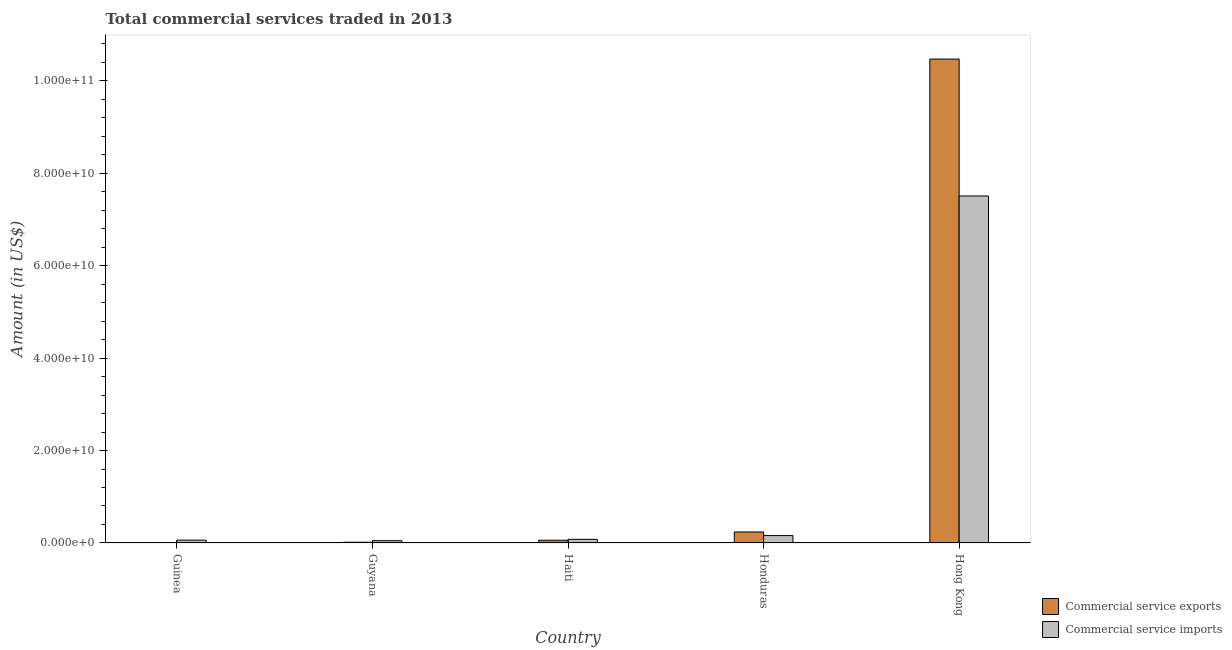How many different coloured bars are there?
Offer a terse response. 2. How many groups of bars are there?
Your answer should be very brief. 5. Are the number of bars on each tick of the X-axis equal?
Provide a short and direct response. Yes. What is the label of the 4th group of bars from the left?
Offer a very short reply. Honduras. In how many cases, is the number of bars for a given country not equal to the number of legend labels?
Keep it short and to the point. 0. What is the amount of commercial service exports in Honduras?
Your answer should be compact. 2.39e+09. Across all countries, what is the maximum amount of commercial service imports?
Your answer should be very brief. 7.50e+1. Across all countries, what is the minimum amount of commercial service imports?
Provide a short and direct response. 5.00e+08. In which country was the amount of commercial service exports maximum?
Provide a succinct answer. Hong Kong. In which country was the amount of commercial service exports minimum?
Provide a succinct answer. Guinea. What is the total amount of commercial service imports in the graph?
Ensure brevity in your answer.  7.86e+1. What is the difference between the amount of commercial service imports in Guyana and that in Haiti?
Give a very brief answer. -2.91e+08. What is the difference between the amount of commercial service imports in Honduras and the amount of commercial service exports in Guinea?
Your answer should be very brief. 1.50e+09. What is the average amount of commercial service imports per country?
Make the answer very short. 1.57e+1. What is the difference between the amount of commercial service imports and amount of commercial service exports in Haiti?
Provide a short and direct response. 1.96e+08. In how many countries, is the amount of commercial service imports greater than 64000000000 US$?
Your answer should be very brief. 1. What is the ratio of the amount of commercial service imports in Guinea to that in Guyana?
Provide a short and direct response. 1.24. Is the amount of commercial service imports in Haiti less than that in Honduras?
Provide a succinct answer. Yes. What is the difference between the highest and the second highest amount of commercial service exports?
Your answer should be compact. 1.02e+11. What is the difference between the highest and the lowest amount of commercial service exports?
Offer a very short reply. 1.05e+11. In how many countries, is the amount of commercial service exports greater than the average amount of commercial service exports taken over all countries?
Make the answer very short. 1. What does the 2nd bar from the left in Guyana represents?
Your answer should be very brief. Commercial service imports. What does the 2nd bar from the right in Hong Kong represents?
Your answer should be compact. Commercial service exports. What is the difference between two consecutive major ticks on the Y-axis?
Offer a terse response. 2.00e+1. Are the values on the major ticks of Y-axis written in scientific E-notation?
Your response must be concise. Yes. Does the graph contain any zero values?
Provide a short and direct response. No. Where does the legend appear in the graph?
Provide a short and direct response. Bottom right. How many legend labels are there?
Offer a terse response. 2. How are the legend labels stacked?
Provide a short and direct response. Vertical. What is the title of the graph?
Provide a short and direct response. Total commercial services traded in 2013. Does "Central government" appear as one of the legend labels in the graph?
Offer a terse response. No. What is the label or title of the Y-axis?
Give a very brief answer. Amount (in US$). What is the Amount (in US$) of Commercial service exports in Guinea?
Your answer should be very brief. 1.00e+08. What is the Amount (in US$) in Commercial service imports in Guinea?
Provide a succinct answer. 6.19e+08. What is the Amount (in US$) of Commercial service exports in Guyana?
Offer a very short reply. 1.65e+08. What is the Amount (in US$) of Commercial service imports in Guyana?
Give a very brief answer. 5.00e+08. What is the Amount (in US$) of Commercial service exports in Haiti?
Provide a short and direct response. 5.95e+08. What is the Amount (in US$) of Commercial service imports in Haiti?
Offer a very short reply. 7.92e+08. What is the Amount (in US$) in Commercial service exports in Honduras?
Ensure brevity in your answer.  2.39e+09. What is the Amount (in US$) in Commercial service imports in Honduras?
Make the answer very short. 1.60e+09. What is the Amount (in US$) in Commercial service exports in Hong Kong?
Make the answer very short. 1.05e+11. What is the Amount (in US$) in Commercial service imports in Hong Kong?
Provide a short and direct response. 7.50e+1. Across all countries, what is the maximum Amount (in US$) in Commercial service exports?
Keep it short and to the point. 1.05e+11. Across all countries, what is the maximum Amount (in US$) of Commercial service imports?
Make the answer very short. 7.50e+1. Across all countries, what is the minimum Amount (in US$) in Commercial service exports?
Offer a very short reply. 1.00e+08. Across all countries, what is the minimum Amount (in US$) in Commercial service imports?
Your response must be concise. 5.00e+08. What is the total Amount (in US$) of Commercial service exports in the graph?
Your response must be concise. 1.08e+11. What is the total Amount (in US$) of Commercial service imports in the graph?
Offer a terse response. 7.86e+1. What is the difference between the Amount (in US$) in Commercial service exports in Guinea and that in Guyana?
Provide a succinct answer. -6.44e+07. What is the difference between the Amount (in US$) in Commercial service imports in Guinea and that in Guyana?
Offer a terse response. 1.19e+08. What is the difference between the Amount (in US$) in Commercial service exports in Guinea and that in Haiti?
Keep it short and to the point. -4.95e+08. What is the difference between the Amount (in US$) of Commercial service imports in Guinea and that in Haiti?
Provide a short and direct response. -1.73e+08. What is the difference between the Amount (in US$) of Commercial service exports in Guinea and that in Honduras?
Your answer should be very brief. -2.29e+09. What is the difference between the Amount (in US$) in Commercial service imports in Guinea and that in Honduras?
Give a very brief answer. -9.85e+08. What is the difference between the Amount (in US$) in Commercial service exports in Guinea and that in Hong Kong?
Provide a succinct answer. -1.05e+11. What is the difference between the Amount (in US$) of Commercial service imports in Guinea and that in Hong Kong?
Ensure brevity in your answer.  -7.44e+1. What is the difference between the Amount (in US$) of Commercial service exports in Guyana and that in Haiti?
Provide a short and direct response. -4.31e+08. What is the difference between the Amount (in US$) in Commercial service imports in Guyana and that in Haiti?
Provide a succinct answer. -2.91e+08. What is the difference between the Amount (in US$) in Commercial service exports in Guyana and that in Honduras?
Make the answer very short. -2.22e+09. What is the difference between the Amount (in US$) in Commercial service imports in Guyana and that in Honduras?
Provide a short and direct response. -1.10e+09. What is the difference between the Amount (in US$) in Commercial service exports in Guyana and that in Hong Kong?
Make the answer very short. -1.04e+11. What is the difference between the Amount (in US$) in Commercial service imports in Guyana and that in Hong Kong?
Offer a very short reply. -7.45e+1. What is the difference between the Amount (in US$) in Commercial service exports in Haiti and that in Honduras?
Offer a very short reply. -1.79e+09. What is the difference between the Amount (in US$) in Commercial service imports in Haiti and that in Honduras?
Your response must be concise. -8.13e+08. What is the difference between the Amount (in US$) of Commercial service exports in Haiti and that in Hong Kong?
Offer a terse response. -1.04e+11. What is the difference between the Amount (in US$) in Commercial service imports in Haiti and that in Hong Kong?
Keep it short and to the point. -7.43e+1. What is the difference between the Amount (in US$) of Commercial service exports in Honduras and that in Hong Kong?
Ensure brevity in your answer.  -1.02e+11. What is the difference between the Amount (in US$) in Commercial service imports in Honduras and that in Hong Kong?
Make the answer very short. -7.34e+1. What is the difference between the Amount (in US$) of Commercial service exports in Guinea and the Amount (in US$) of Commercial service imports in Guyana?
Your response must be concise. -4.00e+08. What is the difference between the Amount (in US$) of Commercial service exports in Guinea and the Amount (in US$) of Commercial service imports in Haiti?
Your response must be concise. -6.91e+08. What is the difference between the Amount (in US$) of Commercial service exports in Guinea and the Amount (in US$) of Commercial service imports in Honduras?
Your answer should be very brief. -1.50e+09. What is the difference between the Amount (in US$) of Commercial service exports in Guinea and the Amount (in US$) of Commercial service imports in Hong Kong?
Provide a short and direct response. -7.49e+1. What is the difference between the Amount (in US$) in Commercial service exports in Guyana and the Amount (in US$) in Commercial service imports in Haiti?
Keep it short and to the point. -6.27e+08. What is the difference between the Amount (in US$) in Commercial service exports in Guyana and the Amount (in US$) in Commercial service imports in Honduras?
Provide a short and direct response. -1.44e+09. What is the difference between the Amount (in US$) of Commercial service exports in Guyana and the Amount (in US$) of Commercial service imports in Hong Kong?
Provide a short and direct response. -7.49e+1. What is the difference between the Amount (in US$) of Commercial service exports in Haiti and the Amount (in US$) of Commercial service imports in Honduras?
Give a very brief answer. -1.01e+09. What is the difference between the Amount (in US$) of Commercial service exports in Haiti and the Amount (in US$) of Commercial service imports in Hong Kong?
Offer a terse response. -7.45e+1. What is the difference between the Amount (in US$) in Commercial service exports in Honduras and the Amount (in US$) in Commercial service imports in Hong Kong?
Offer a terse response. -7.27e+1. What is the average Amount (in US$) of Commercial service exports per country?
Keep it short and to the point. 2.16e+1. What is the average Amount (in US$) in Commercial service imports per country?
Your response must be concise. 1.57e+1. What is the difference between the Amount (in US$) of Commercial service exports and Amount (in US$) of Commercial service imports in Guinea?
Offer a terse response. -5.19e+08. What is the difference between the Amount (in US$) in Commercial service exports and Amount (in US$) in Commercial service imports in Guyana?
Ensure brevity in your answer.  -3.36e+08. What is the difference between the Amount (in US$) in Commercial service exports and Amount (in US$) in Commercial service imports in Haiti?
Keep it short and to the point. -1.96e+08. What is the difference between the Amount (in US$) of Commercial service exports and Amount (in US$) of Commercial service imports in Honduras?
Make the answer very short. 7.81e+08. What is the difference between the Amount (in US$) in Commercial service exports and Amount (in US$) in Commercial service imports in Hong Kong?
Give a very brief answer. 2.96e+1. What is the ratio of the Amount (in US$) of Commercial service exports in Guinea to that in Guyana?
Give a very brief answer. 0.61. What is the ratio of the Amount (in US$) of Commercial service imports in Guinea to that in Guyana?
Keep it short and to the point. 1.24. What is the ratio of the Amount (in US$) of Commercial service exports in Guinea to that in Haiti?
Offer a terse response. 0.17. What is the ratio of the Amount (in US$) in Commercial service imports in Guinea to that in Haiti?
Offer a terse response. 0.78. What is the ratio of the Amount (in US$) in Commercial service exports in Guinea to that in Honduras?
Provide a succinct answer. 0.04. What is the ratio of the Amount (in US$) of Commercial service imports in Guinea to that in Honduras?
Offer a very short reply. 0.39. What is the ratio of the Amount (in US$) in Commercial service exports in Guinea to that in Hong Kong?
Offer a very short reply. 0. What is the ratio of the Amount (in US$) in Commercial service imports in Guinea to that in Hong Kong?
Your response must be concise. 0.01. What is the ratio of the Amount (in US$) of Commercial service exports in Guyana to that in Haiti?
Your response must be concise. 0.28. What is the ratio of the Amount (in US$) in Commercial service imports in Guyana to that in Haiti?
Provide a succinct answer. 0.63. What is the ratio of the Amount (in US$) of Commercial service exports in Guyana to that in Honduras?
Your response must be concise. 0.07. What is the ratio of the Amount (in US$) in Commercial service imports in Guyana to that in Honduras?
Give a very brief answer. 0.31. What is the ratio of the Amount (in US$) in Commercial service exports in Guyana to that in Hong Kong?
Offer a very short reply. 0. What is the ratio of the Amount (in US$) in Commercial service imports in Guyana to that in Hong Kong?
Provide a succinct answer. 0.01. What is the ratio of the Amount (in US$) of Commercial service exports in Haiti to that in Honduras?
Your answer should be compact. 0.25. What is the ratio of the Amount (in US$) in Commercial service imports in Haiti to that in Honduras?
Keep it short and to the point. 0.49. What is the ratio of the Amount (in US$) of Commercial service exports in Haiti to that in Hong Kong?
Your response must be concise. 0.01. What is the ratio of the Amount (in US$) in Commercial service imports in Haiti to that in Hong Kong?
Provide a short and direct response. 0.01. What is the ratio of the Amount (in US$) of Commercial service exports in Honduras to that in Hong Kong?
Offer a terse response. 0.02. What is the ratio of the Amount (in US$) of Commercial service imports in Honduras to that in Hong Kong?
Provide a succinct answer. 0.02. What is the difference between the highest and the second highest Amount (in US$) of Commercial service exports?
Make the answer very short. 1.02e+11. What is the difference between the highest and the second highest Amount (in US$) in Commercial service imports?
Provide a succinct answer. 7.34e+1. What is the difference between the highest and the lowest Amount (in US$) of Commercial service exports?
Keep it short and to the point. 1.05e+11. What is the difference between the highest and the lowest Amount (in US$) in Commercial service imports?
Your answer should be very brief. 7.45e+1. 